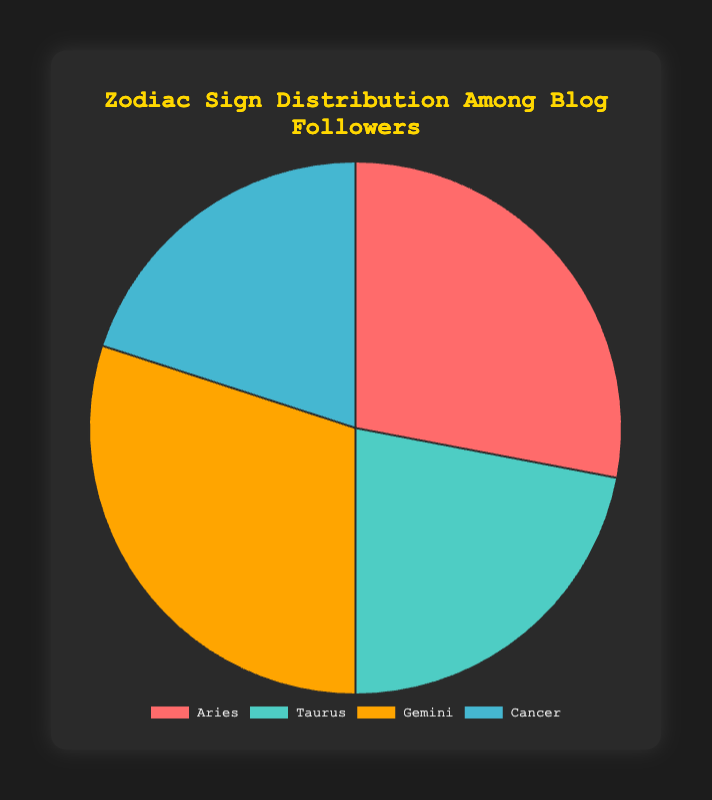what percentage of blog followers are Gemini? The pie chart visualizes the distribution percentages of blog followers by zodiac sign. The segment representing Gemini is labeled with a percentage value.
Answer: 30% Which zodiac sign has the highest engagement rate numerically? The engagement rate can be inferred from the color-coded segments in the pie chart. The highest engagement rate would correspond to the segment with the highest associated percentage. Each segment represents a specific zodiac sign with its engagement rate mentioned.
Answer: Gemini How many more followers does Aries have compared to Cancer? Convert the percentage values into actual follower numbers based on the given data. Aries has 1120 followers, and Cancer has 800 followers. Subtract the number of Cancer followers from Aries followers (1120 - 800).
Answer: 320 Compare the engagement rates between Taurus and Cancer. The engagement rates for Taurus and Cancer are listed as additional data attributes in the pie chart legend or tooltips. Taurus has an engagement rate of 33 while Cancer has 28. Subtract Cancer's engagement rate from Taurus's engagement rate (33 - 28).
Answer: 5 What's the total percentage of followers for non-Gemini signs? Add the percentage values of Aries, Taurus, and Cancer (28% + 22% + 20%) and subtract the percentage value of Gemini from 100% (100% - 30%).
Answer: 70% Which zodiac sign comments the most on the blog? The pie chart includes data on comments for each zodiac sign. Identify the segment with the highest comment count. Gemini has the highest comment count with 410 comments.
Answer: Gemini Which two zodiac signs together account for more than half of the blog followers? Start by adding percentages of combinations of two zodiac signs and check which combination totals more than 50%. Aries (28%) and Gemini (30%) together account for 58% (28% + 30%).
Answer: Aries and Gemini What is the average number of comments per sign? Calculate the total number of comments and divide by the number of signs. The sum of comments is (350 + 290 + 410 + 220) = 1270, and the average with 4 signs is 1270/4.
Answer: 317.5 Which zodiac sign has the least number of followers, and what color represents it in the chart? Look at the follower counts provided for each sign. Cancer has the least number of followers at 800. Identify the color for Cancer in the chart.
Answer: Cancer (Blue) 